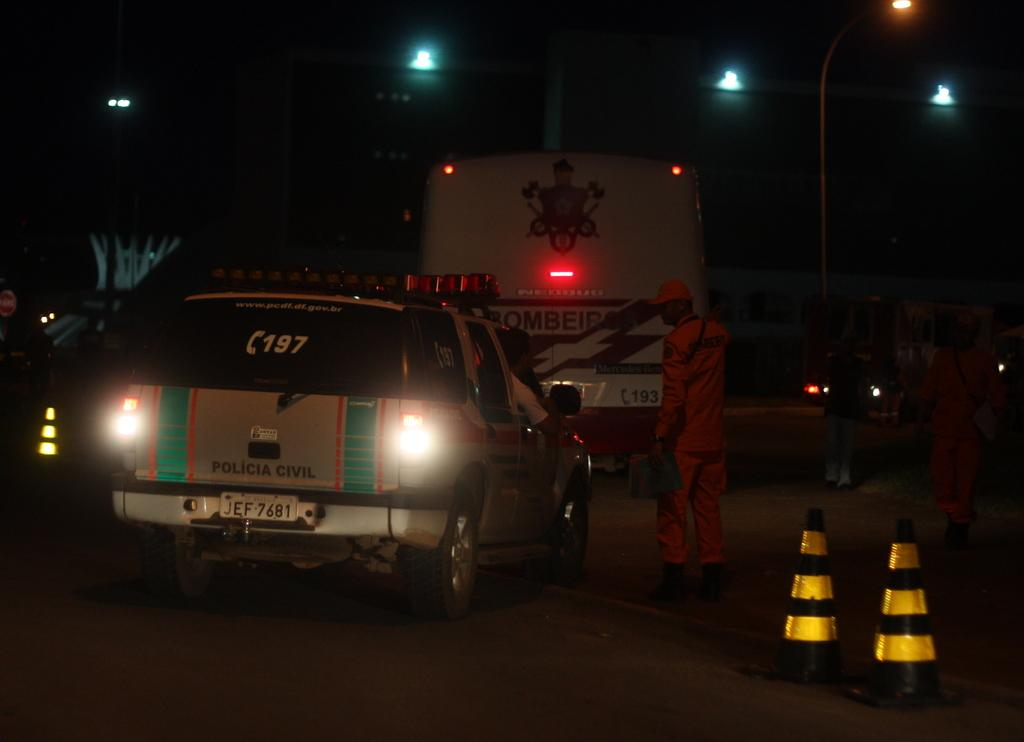What can be seen on the road in the image? There are vehicles on the road in the image. What else is visible near the road in the image? There are people standing near the road in the image. What safety measures are present in the image? There are road divider cones in the image. What structures are visible in the image? There are poles visible in the image. What can be used for illumination in the image? There are lights present in the image. Where is the coal being stored in the image? There is no coal present in the image. Can you describe the box that is being carried by the fly in the image? There is no fly or box present in the image. 